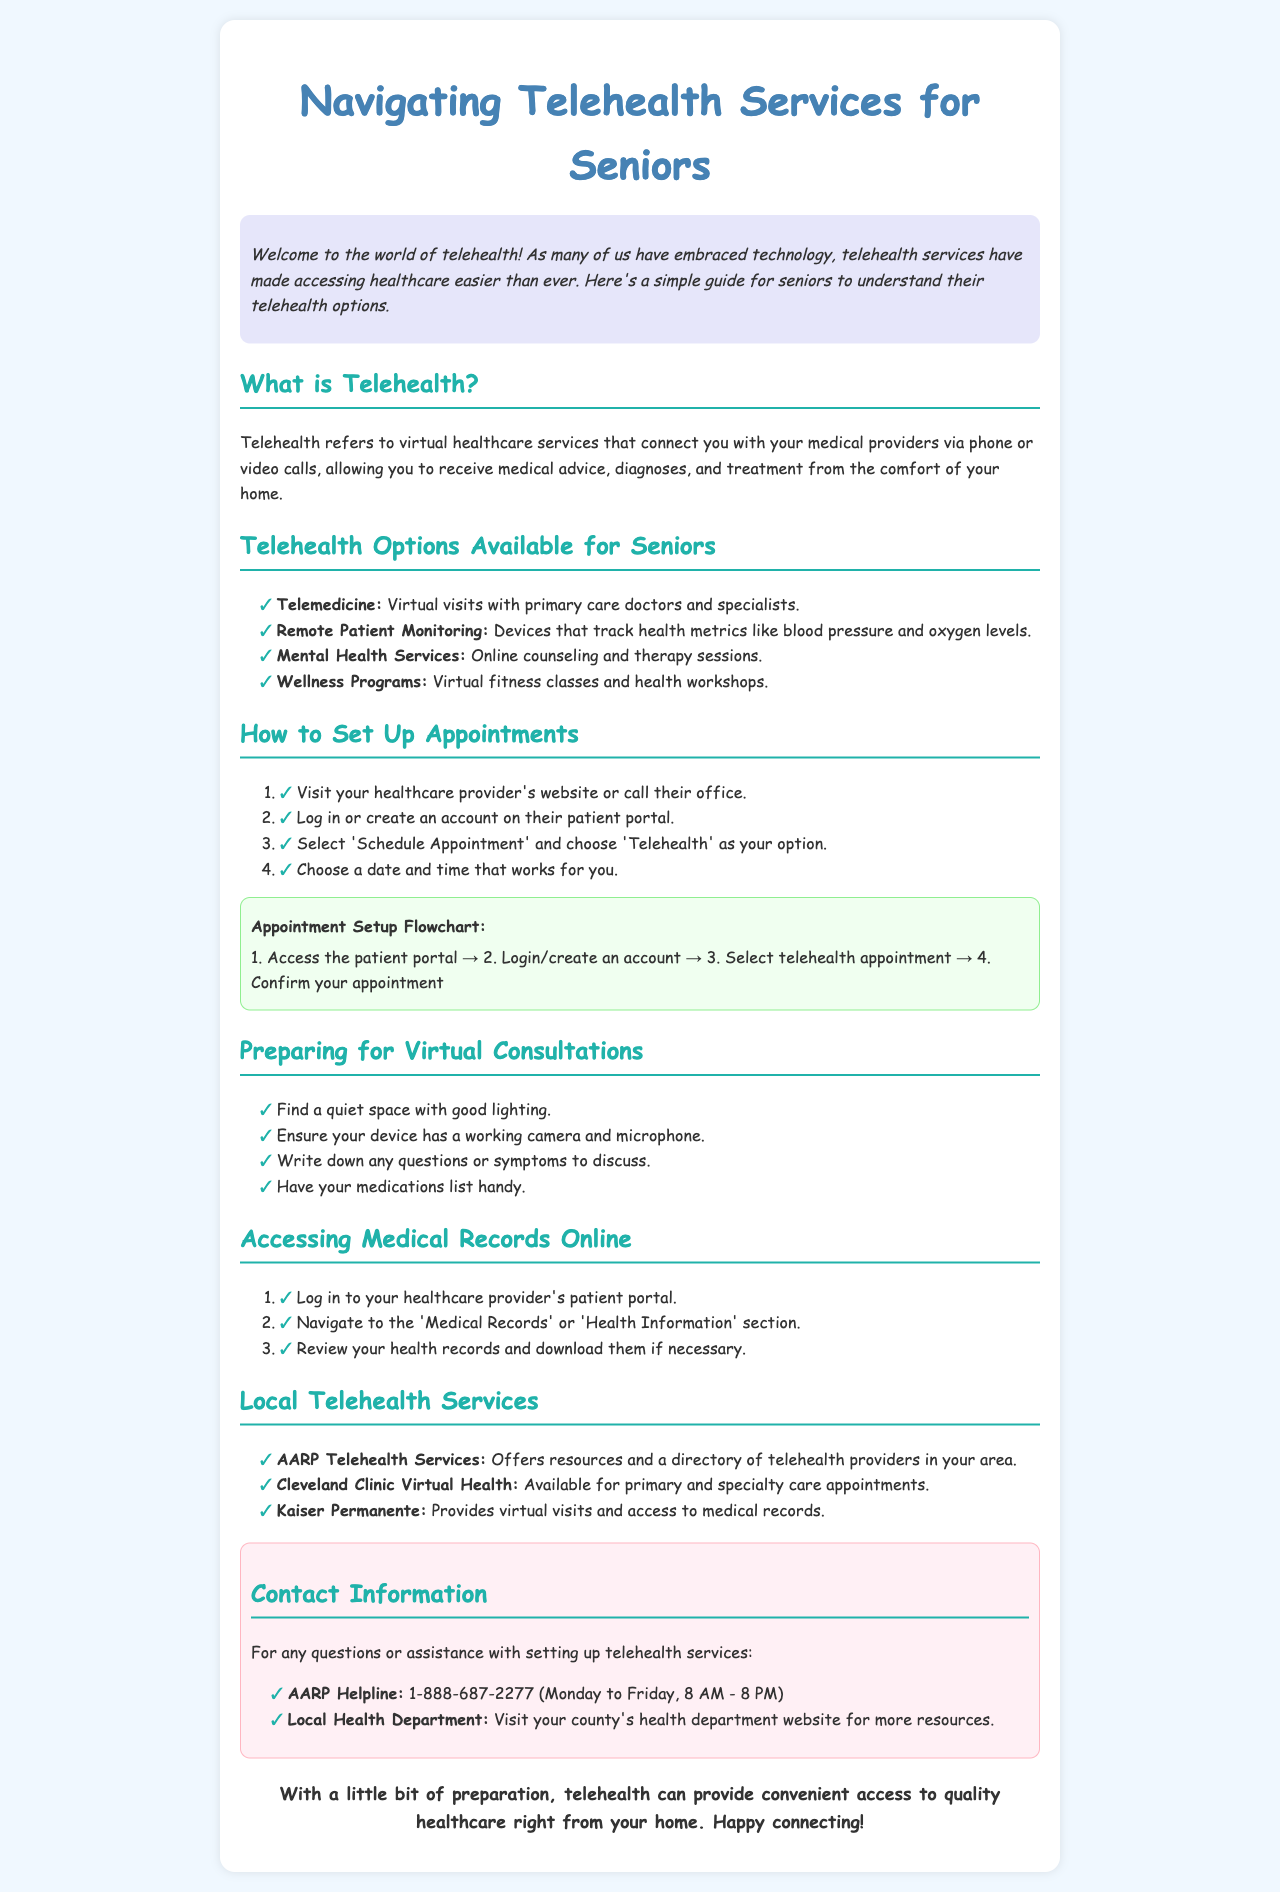What is Telehealth? Telehealth is defined in the document as virtual healthcare services that connect you with your medical providers via phone or video calls.
Answer: Virtual healthcare services What are the telehealth options available for seniors? The document lists several options available for seniors, including telemedicine, remote patient monitoring, mental health services, and wellness programs.
Answer: Telemedicine, remote patient monitoring, mental health services, wellness programs How do you schedule a telehealth appointment? The document outlines four steps to schedule a telehealth appointment, starting with visiting the healthcare provider's website or calling their office.
Answer: Visit the website or call the office What is the AARP Helpline number? The document provides the AARP Helpline as a resource for questions or assistance, including a specific number.
Answer: 1-888-687-2277 What should you prepare for virtual consultations? The document states several things to prepare for a virtual consultation, such as finding a quiet space and ensuring your device has a working camera.
Answer: Quiet space, working camera What type of information can you access online? The document mentions that you can access medical records online through your healthcare provider's patient portal.
Answer: Medical records What does the appointment setup flowchart outline? The flowchart includes the sequential steps to set up an appointment as highlighted in the document.
Answer: Access patient portal, login, select telehealth appointment, confirm What is the contact information for local telehealth services? The document lists contact information, specifically for AARP in relation to telehealth services.
Answer: AARP Helpline: 1-888-687-2277 What color is used for the background of the document? The document specifies a light background color for easy readability.
Answer: Light blue (F0F8FF) 